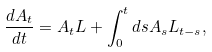<formula> <loc_0><loc_0><loc_500><loc_500>\frac { d A _ { t } } { d t } = A _ { t } L + \int _ { 0 } ^ { t } d s A _ { s } L _ { t - s } ,</formula> 